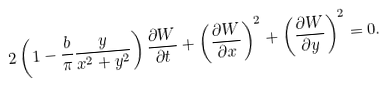Convert formula to latex. <formula><loc_0><loc_0><loc_500><loc_500>2 \left ( 1 - \frac { b } { \pi } \frac { y } { x ^ { 2 } + y ^ { 2 } } \right ) \frac { \partial W } { \partial t } + \left ( \frac { \partial W } { \partial x } \right ) ^ { 2 } + \left ( \frac { \partial W } { \partial y } \right ) ^ { 2 } = 0 .</formula> 